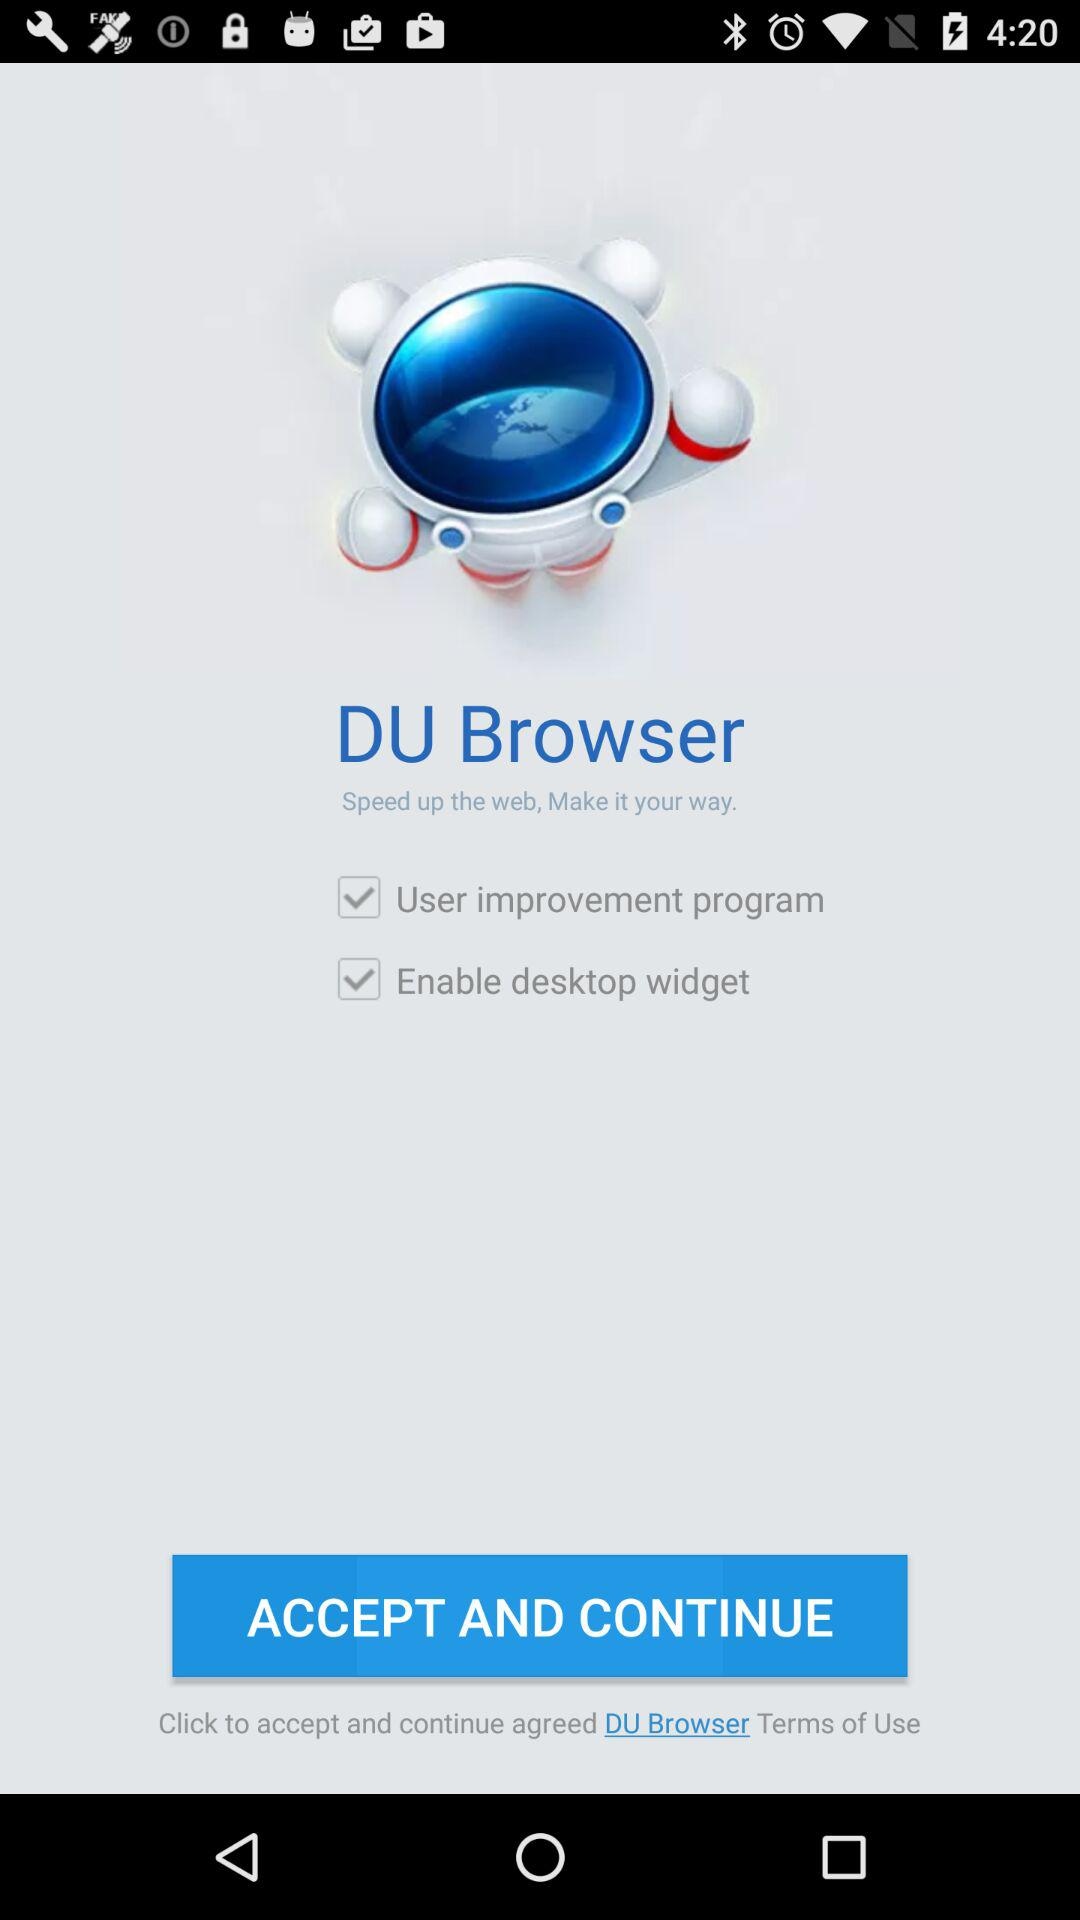What features are there in the "DU browser"? The features are "User improvement program" and "Enable desktop widget". 